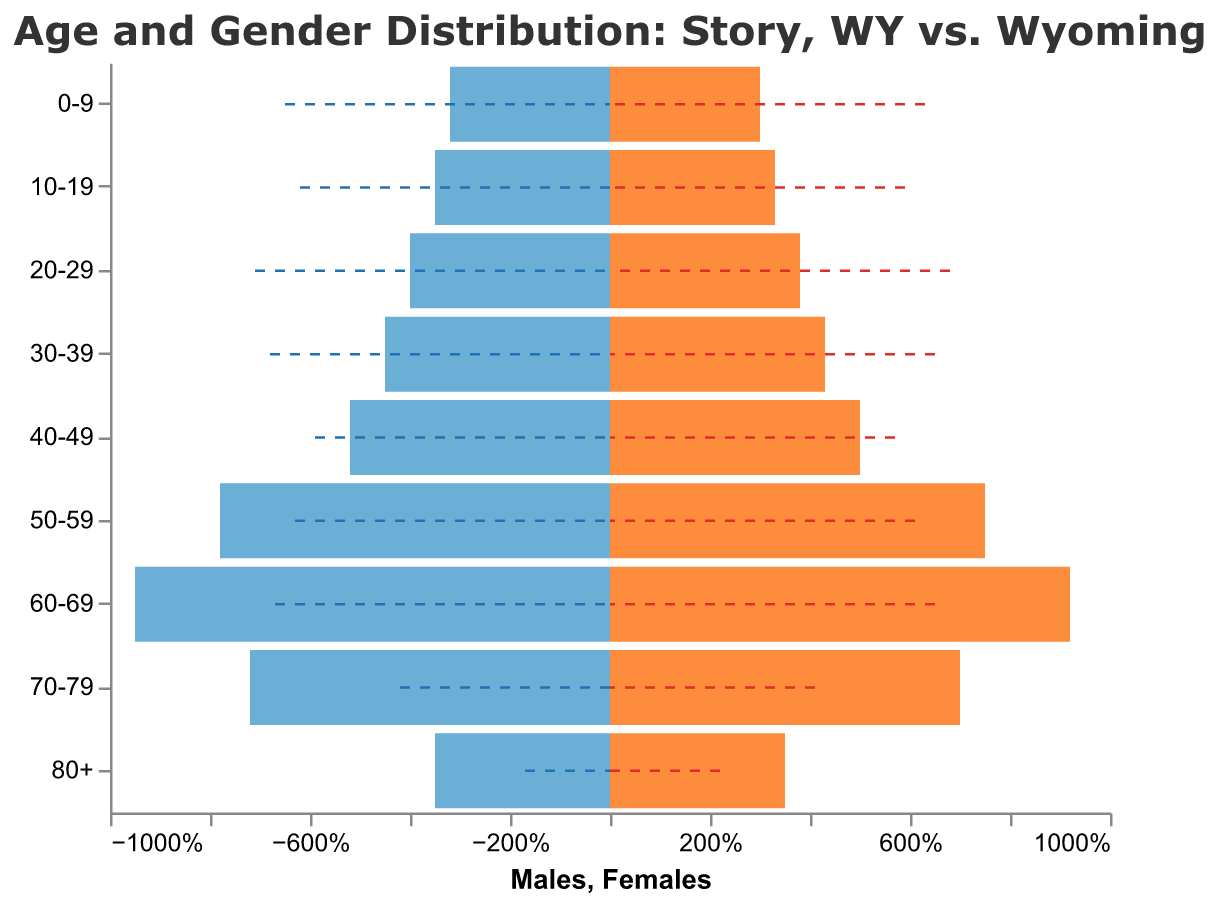What is the title of the chart? The title is found at the top of the chart. It helps in understanding the overall subject of the data.
Answer: Age and Gender Distribution: Story, WY vs. Wyoming Which age group has the highest percentage of males in Story? By comparing the values for males in Story across all age groups, we see that the 60-69 age group has the highest percentage (-9.5%).
Answer: 60-69 How does the percentage of females aged 0-9 in Story compare to females aged 0-9 in Wyoming? Look at the data for females in the 0-9 age group. In Story it is 3.0%, whereas in Wyoming it is 6.3%.
Answer: Story has fewer females aged 0-9 than Wyoming What is the difference between male and female population percentages in Story for the age group 50-59? Subtract the male percentage from the female percentage for this age group: 7.5% - 7.8% = -0.3%.
Answer: -0.3% Which age group shows the smallest gender gap in Story's population? Calculate the absolute difference between male and female percentages for each age group. The 0-9 age group has the smallest gap:
Answer: 0-9 In which age group does Story have a larger population percentage of females compared to the state average? Compare the percentages of females in different age groups in Story and Wyoming. The 60-69 age group in Story has 9.2% females, while Wyoming has 6.5%.
Answer: 60-69 How does the male population percentage in Story's 80+ age group compare to Wyoming's 80+ age group? Compare the male percentage values for the 80+ age group. Story has -3.5% while Wyoming has -1.7%.
Answer: Story has a higher male population percentage in 80+ What is the difference between the oldest age group male population in Story and Wyoming? Subtract the Wyoming percentage from the Story percentage for males aged 80+: -3.5% - (-1.7%) = -1.8%.
Answer: -1.8% Which age group in Story has a higher female population percentage than male? By reviewing the data, the age groups 0-9, 10-19, 20-29, and 60-69 in Story have higher percentage of females than males.
Answer: Four age groups Does Story or Wyoming have a higher percentage of people aged 20-29? Compare both the male and female percentages for the 20-29 age group. Wyoming has higher percentages: -7.1% males and 6.8% females compared to Story's -4.0% males and 3.8% females.
Answer: Wyoming 